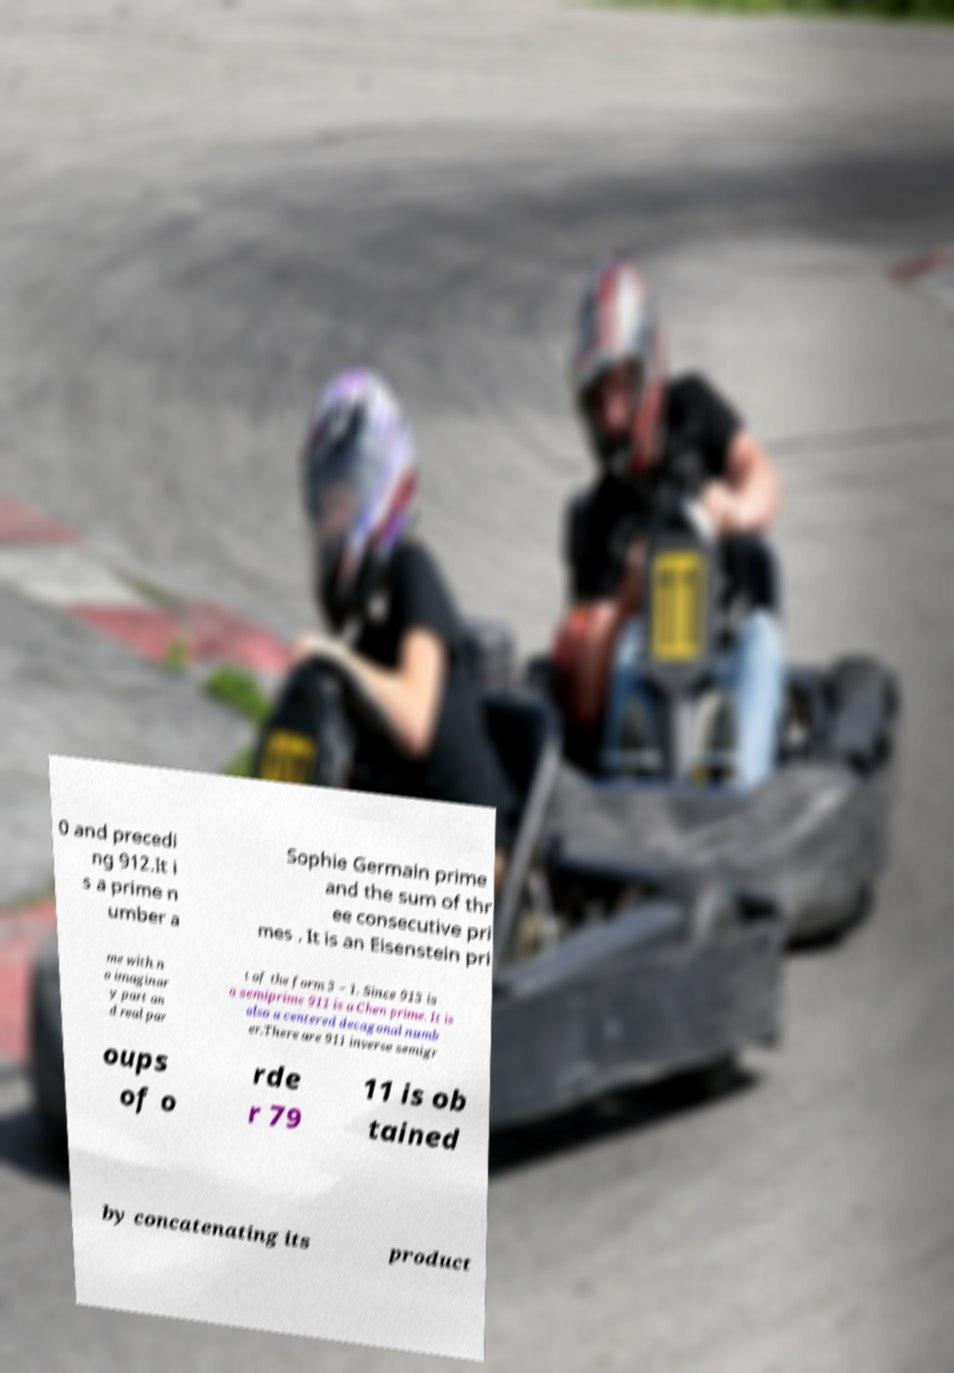Can you accurately transcribe the text from the provided image for me? 0 and precedi ng 912.It i s a prime n umber a Sophie Germain prime and the sum of thr ee consecutive pri mes . It is an Eisenstein pri me with n o imaginar y part an d real par t of the form 3 − 1. Since 913 is a semiprime 911 is a Chen prime. It is also a centered decagonal numb er.There are 911 inverse semigr oups of o rde r 79 11 is ob tained by concatenating its product 